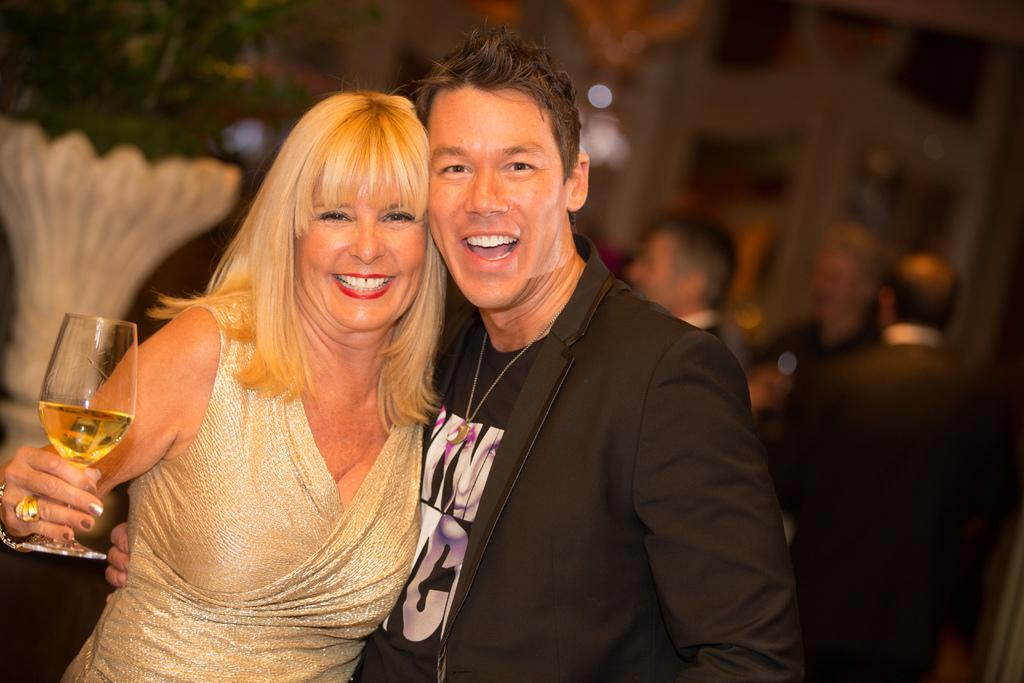Who is present in the image? There is a man and a woman in the image. What are the facial expressions of the people in the image? The man and the woman are both smiling. What is the woman holding in the image? The woman is holding a glass with a drink in it. What can be observed about the man's attire in the image? The man is wearing a blazer. How would you describe the background of the image? The background of the image is blurry. What type of dock can be seen in the image? There is no dock present in the image. What is the aftermath of the event depicted in the image? The image does not depict an event, so there is no aftermath to describe. 